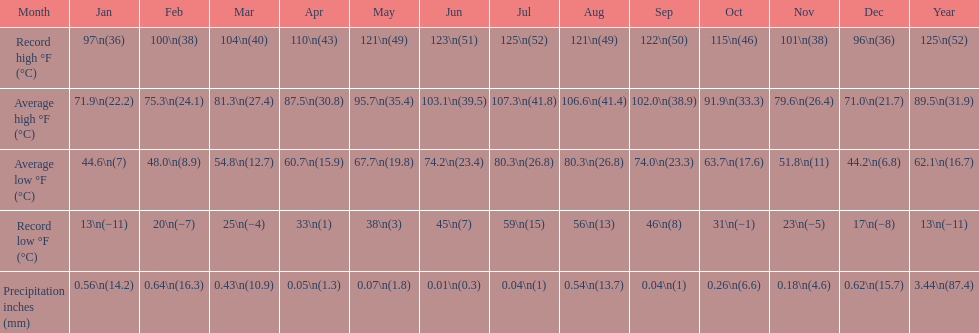How many months saw record lows below freezing? 7. 